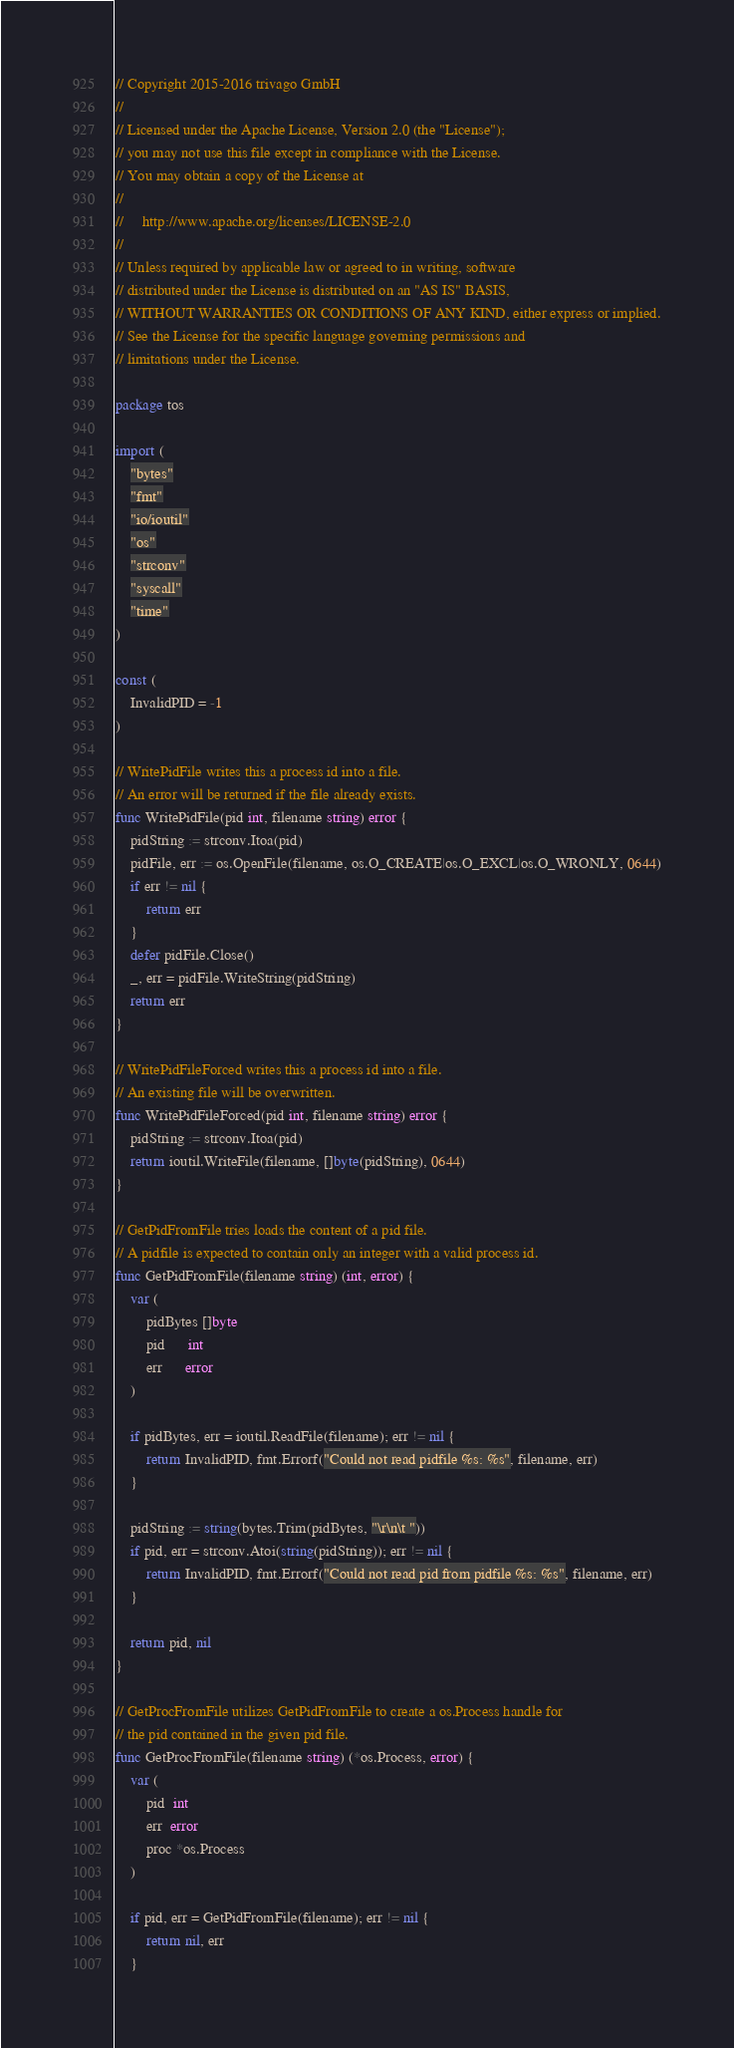Convert code to text. <code><loc_0><loc_0><loc_500><loc_500><_Go_>// Copyright 2015-2016 trivago GmbH
//
// Licensed under the Apache License, Version 2.0 (the "License");
// you may not use this file except in compliance with the License.
// You may obtain a copy of the License at
//
//     http://www.apache.org/licenses/LICENSE-2.0
//
// Unless required by applicable law or agreed to in writing, software
// distributed under the License is distributed on an "AS IS" BASIS,
// WITHOUT WARRANTIES OR CONDITIONS OF ANY KIND, either express or implied.
// See the License for the specific language governing permissions and
// limitations under the License.

package tos

import (
	"bytes"
	"fmt"
	"io/ioutil"
	"os"
	"strconv"
	"syscall"
	"time"
)

const (
	InvalidPID = -1
)

// WritePidFile writes this a process id into a file.
// An error will be returned if the file already exists.
func WritePidFile(pid int, filename string) error {
	pidString := strconv.Itoa(pid)
	pidFile, err := os.OpenFile(filename, os.O_CREATE|os.O_EXCL|os.O_WRONLY, 0644)
	if err != nil {
		return err
	}
	defer pidFile.Close()
	_, err = pidFile.WriteString(pidString)
	return err
}

// WritePidFileForced writes this a process id into a file.
// An existing file will be overwritten.
func WritePidFileForced(pid int, filename string) error {
	pidString := strconv.Itoa(pid)
	return ioutil.WriteFile(filename, []byte(pidString), 0644)
}

// GetPidFromFile tries loads the content of a pid file.
// A pidfile is expected to contain only an integer with a valid process id.
func GetPidFromFile(filename string) (int, error) {
	var (
		pidBytes []byte
		pid      int
		err      error
	)

	if pidBytes, err = ioutil.ReadFile(filename); err != nil {
		return InvalidPID, fmt.Errorf("Could not read pidfile %s: %s", filename, err)
	}

	pidString := string(bytes.Trim(pidBytes, "\r\n\t "))
	if pid, err = strconv.Atoi(string(pidString)); err != nil {
		return InvalidPID, fmt.Errorf("Could not read pid from pidfile %s: %s", filename, err)
	}

	return pid, nil
}

// GetProcFromFile utilizes GetPidFromFile to create a os.Process handle for
// the pid contained in the given pid file.
func GetProcFromFile(filename string) (*os.Process, error) {
	var (
		pid  int
		err  error
		proc *os.Process
	)

	if pid, err = GetPidFromFile(filename); err != nil {
		return nil, err
	}
</code> 